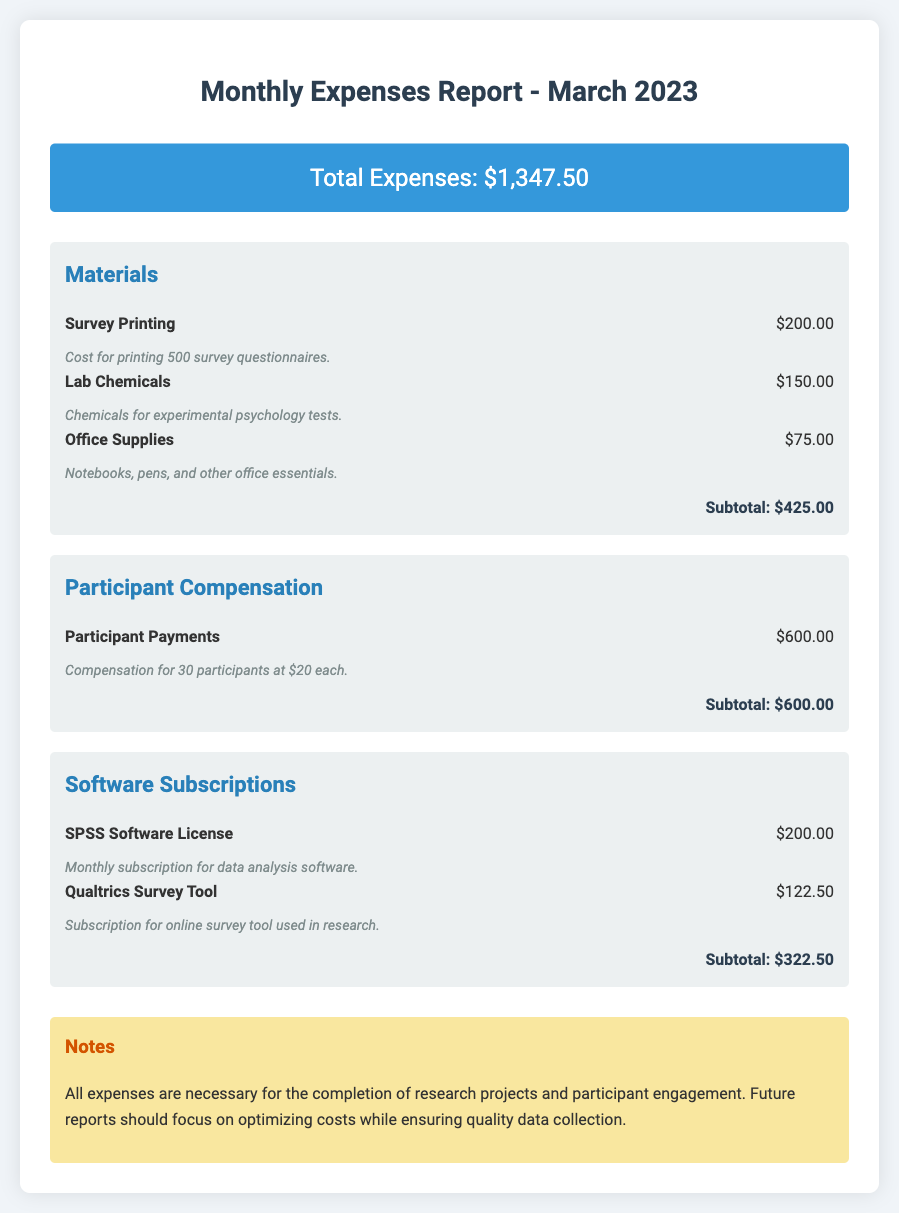what is the total expenses for March 2023? The total expenses is explicitly stated in the document, which sums all costs incurred.
Answer: $1,347.50 how much was spent on materials? The subtotal for materials is calculated from individual item costs listed in the "Materials" category.
Answer: $425.00 how many participants were compensated? The number of participants receiving compensation is provided in the "Participant Compensation" section.
Answer: 30 what is the cost of the SPSS Software License? The cost of SPSS Software License is listed under the "Software Subscriptions" category.
Answer: $200.00 what is the total amount spent on participant compensation? The total for participant compensation is clearly mentioned in the "Participant Compensation" section.
Answer: $600.00 which category had the highest expense? The highest expense category can be determined by comparing subtotals among all listed categories.
Answer: Participant Compensation what is the total amount spent on software subscriptions? The total for software subscriptions is the sum of the costs in that category, which is noted in the document.
Answer: $322.50 how much was spent on lab chemicals? The expenditure on lab chemicals is specified in the "Materials" section of the report.
Answer: $150.00 what notes are provided in the report? The notes section includes remarks about the necessity of expenses for research projects.
Answer: All expenses are necessary for the completion of research projects and participant engagement 